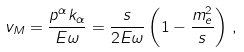Convert formula to latex. <formula><loc_0><loc_0><loc_500><loc_500>v _ { M } = \frac { p ^ { \alpha } k _ { \alpha } } { E \omega } = \frac { s } { 2 E \omega } \left ( 1 - \frac { m _ { e } ^ { 2 } } { s } \right ) \, ,</formula> 